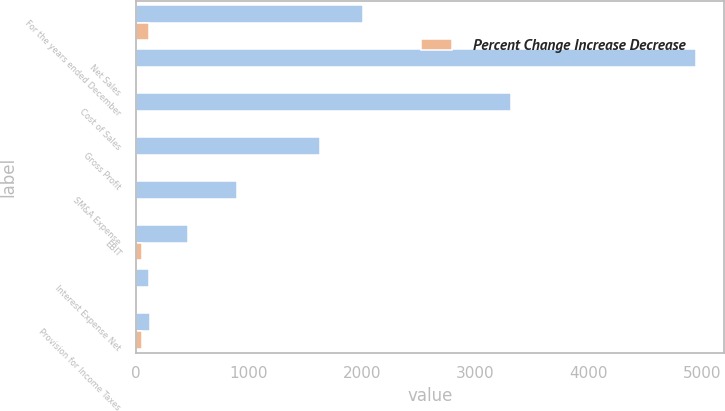Convert chart to OTSL. <chart><loc_0><loc_0><loc_500><loc_500><stacked_bar_chart><ecel><fcel>For the years ended December<fcel>Net Sales<fcel>Cost of Sales<fcel>Gross Profit<fcel>SM&A Expense<fcel>EBIT<fcel>Interest Expense Net<fcel>Provision for Income Taxes<nl><fcel>nan<fcel>2007<fcel>4946.7<fcel>3315.1<fcel>1631.6<fcel>895.9<fcel>458.8<fcel>118.6<fcel>126<nl><fcel>Percent Change Increase Decrease<fcel>118.6<fcel>0.1<fcel>7.7<fcel>12.6<fcel>4.1<fcel>53.8<fcel>2.2<fcel>60.3<nl></chart> 